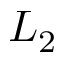<formula> <loc_0><loc_0><loc_500><loc_500>L _ { 2 }</formula> 